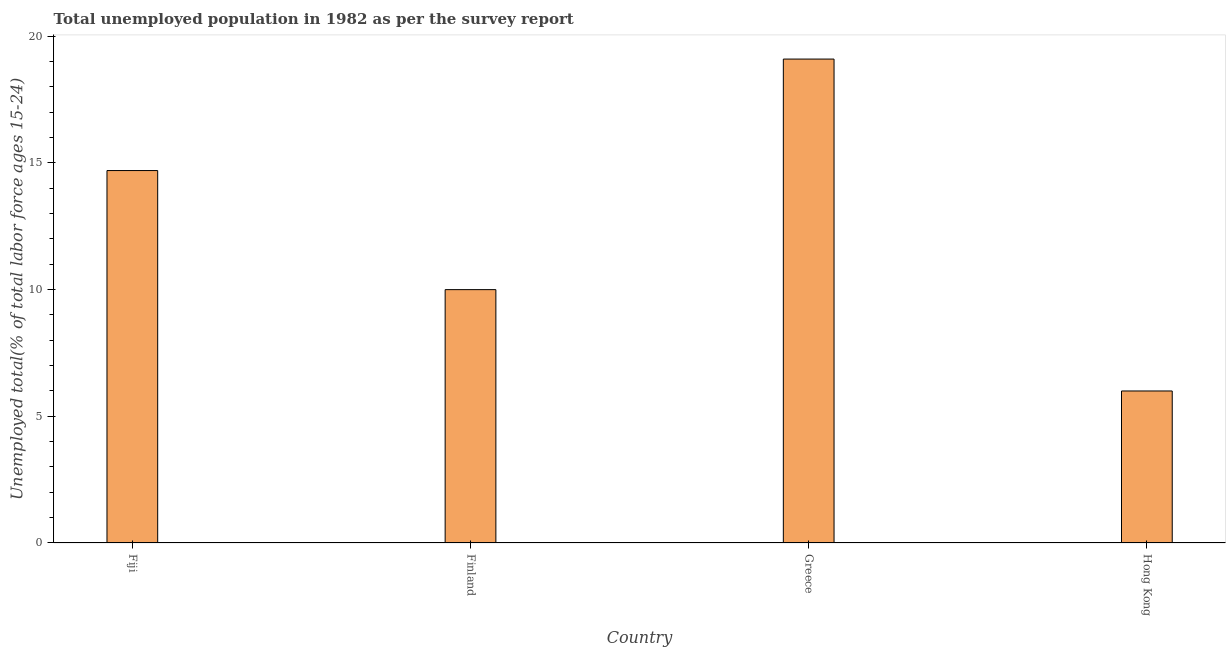Does the graph contain any zero values?
Provide a short and direct response. No. What is the title of the graph?
Your answer should be compact. Total unemployed population in 1982 as per the survey report. What is the label or title of the Y-axis?
Your answer should be very brief. Unemployed total(% of total labor force ages 15-24). What is the unemployed youth in Hong Kong?
Provide a succinct answer. 6. Across all countries, what is the maximum unemployed youth?
Offer a terse response. 19.1. Across all countries, what is the minimum unemployed youth?
Offer a very short reply. 6. In which country was the unemployed youth minimum?
Offer a terse response. Hong Kong. What is the sum of the unemployed youth?
Offer a very short reply. 49.8. What is the difference between the unemployed youth in Fiji and Greece?
Offer a terse response. -4.4. What is the average unemployed youth per country?
Your answer should be compact. 12.45. What is the median unemployed youth?
Make the answer very short. 12.35. In how many countries, is the unemployed youth greater than 11 %?
Provide a succinct answer. 2. What is the ratio of the unemployed youth in Greece to that in Hong Kong?
Provide a short and direct response. 3.18. What is the difference between the highest and the second highest unemployed youth?
Your answer should be very brief. 4.4. Is the sum of the unemployed youth in Fiji and Greece greater than the maximum unemployed youth across all countries?
Provide a succinct answer. Yes. What is the difference between the highest and the lowest unemployed youth?
Provide a short and direct response. 13.1. In how many countries, is the unemployed youth greater than the average unemployed youth taken over all countries?
Give a very brief answer. 2. How many bars are there?
Your answer should be very brief. 4. How many countries are there in the graph?
Ensure brevity in your answer.  4. Are the values on the major ticks of Y-axis written in scientific E-notation?
Offer a terse response. No. What is the Unemployed total(% of total labor force ages 15-24) of Fiji?
Your answer should be very brief. 14.7. What is the Unemployed total(% of total labor force ages 15-24) in Greece?
Ensure brevity in your answer.  19.1. What is the difference between the Unemployed total(% of total labor force ages 15-24) in Fiji and Hong Kong?
Give a very brief answer. 8.7. What is the difference between the Unemployed total(% of total labor force ages 15-24) in Finland and Greece?
Provide a short and direct response. -9.1. What is the difference between the Unemployed total(% of total labor force ages 15-24) in Finland and Hong Kong?
Provide a succinct answer. 4. What is the ratio of the Unemployed total(% of total labor force ages 15-24) in Fiji to that in Finland?
Offer a terse response. 1.47. What is the ratio of the Unemployed total(% of total labor force ages 15-24) in Fiji to that in Greece?
Offer a very short reply. 0.77. What is the ratio of the Unemployed total(% of total labor force ages 15-24) in Fiji to that in Hong Kong?
Your answer should be very brief. 2.45. What is the ratio of the Unemployed total(% of total labor force ages 15-24) in Finland to that in Greece?
Offer a terse response. 0.52. What is the ratio of the Unemployed total(% of total labor force ages 15-24) in Finland to that in Hong Kong?
Make the answer very short. 1.67. What is the ratio of the Unemployed total(% of total labor force ages 15-24) in Greece to that in Hong Kong?
Make the answer very short. 3.18. 